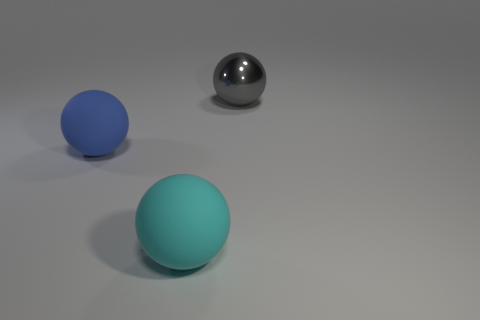Add 3 metallic balls. How many objects exist? 6 Subtract all matte balls. How many balls are left? 1 Subtract all small gray objects. Subtract all matte objects. How many objects are left? 1 Add 3 large rubber objects. How many large rubber objects are left? 5 Add 1 large gray metallic objects. How many large gray metallic objects exist? 2 Subtract 0 cyan cylinders. How many objects are left? 3 